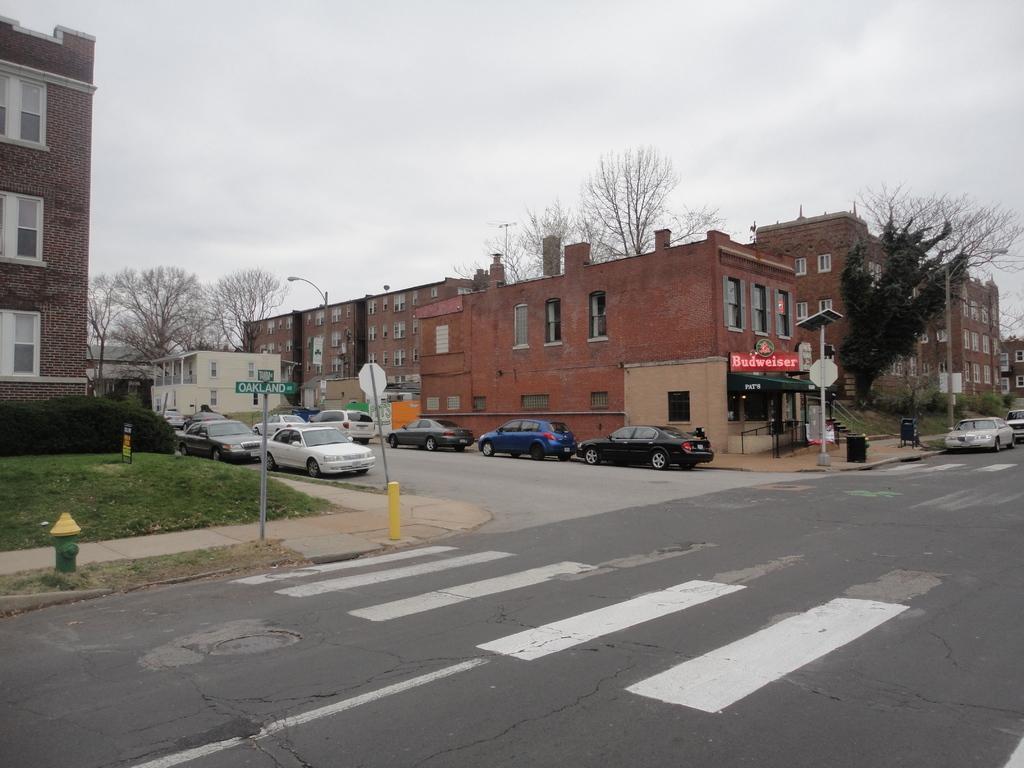Please provide a concise description of this image. In this picture we can see some vehicles parked on the road, On the left side of the vehicles there are poles with boards. On the right side of the vehicles there are buildings, name boards, trees and some objects. Behind the buildings there is the sky. 